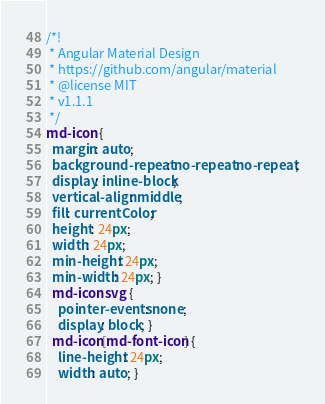Convert code to text. <code><loc_0><loc_0><loc_500><loc_500><_CSS_>/*!
 * Angular Material Design
 * https://github.com/angular/material
 * @license MIT
 * v1.1.1
 */
md-icon {
  margin: auto;
  background-repeat: no-repeat no-repeat;
  display: inline-block;
  vertical-align: middle;
  fill: currentColor;
  height: 24px;
  width: 24px;
  min-height: 24px;
  min-width: 24px; }
  md-icon svg {
    pointer-events: none;
    display: block; }
  md-icon[md-font-icon] {
    line-height: 24px;
    width: auto; }
</code> 